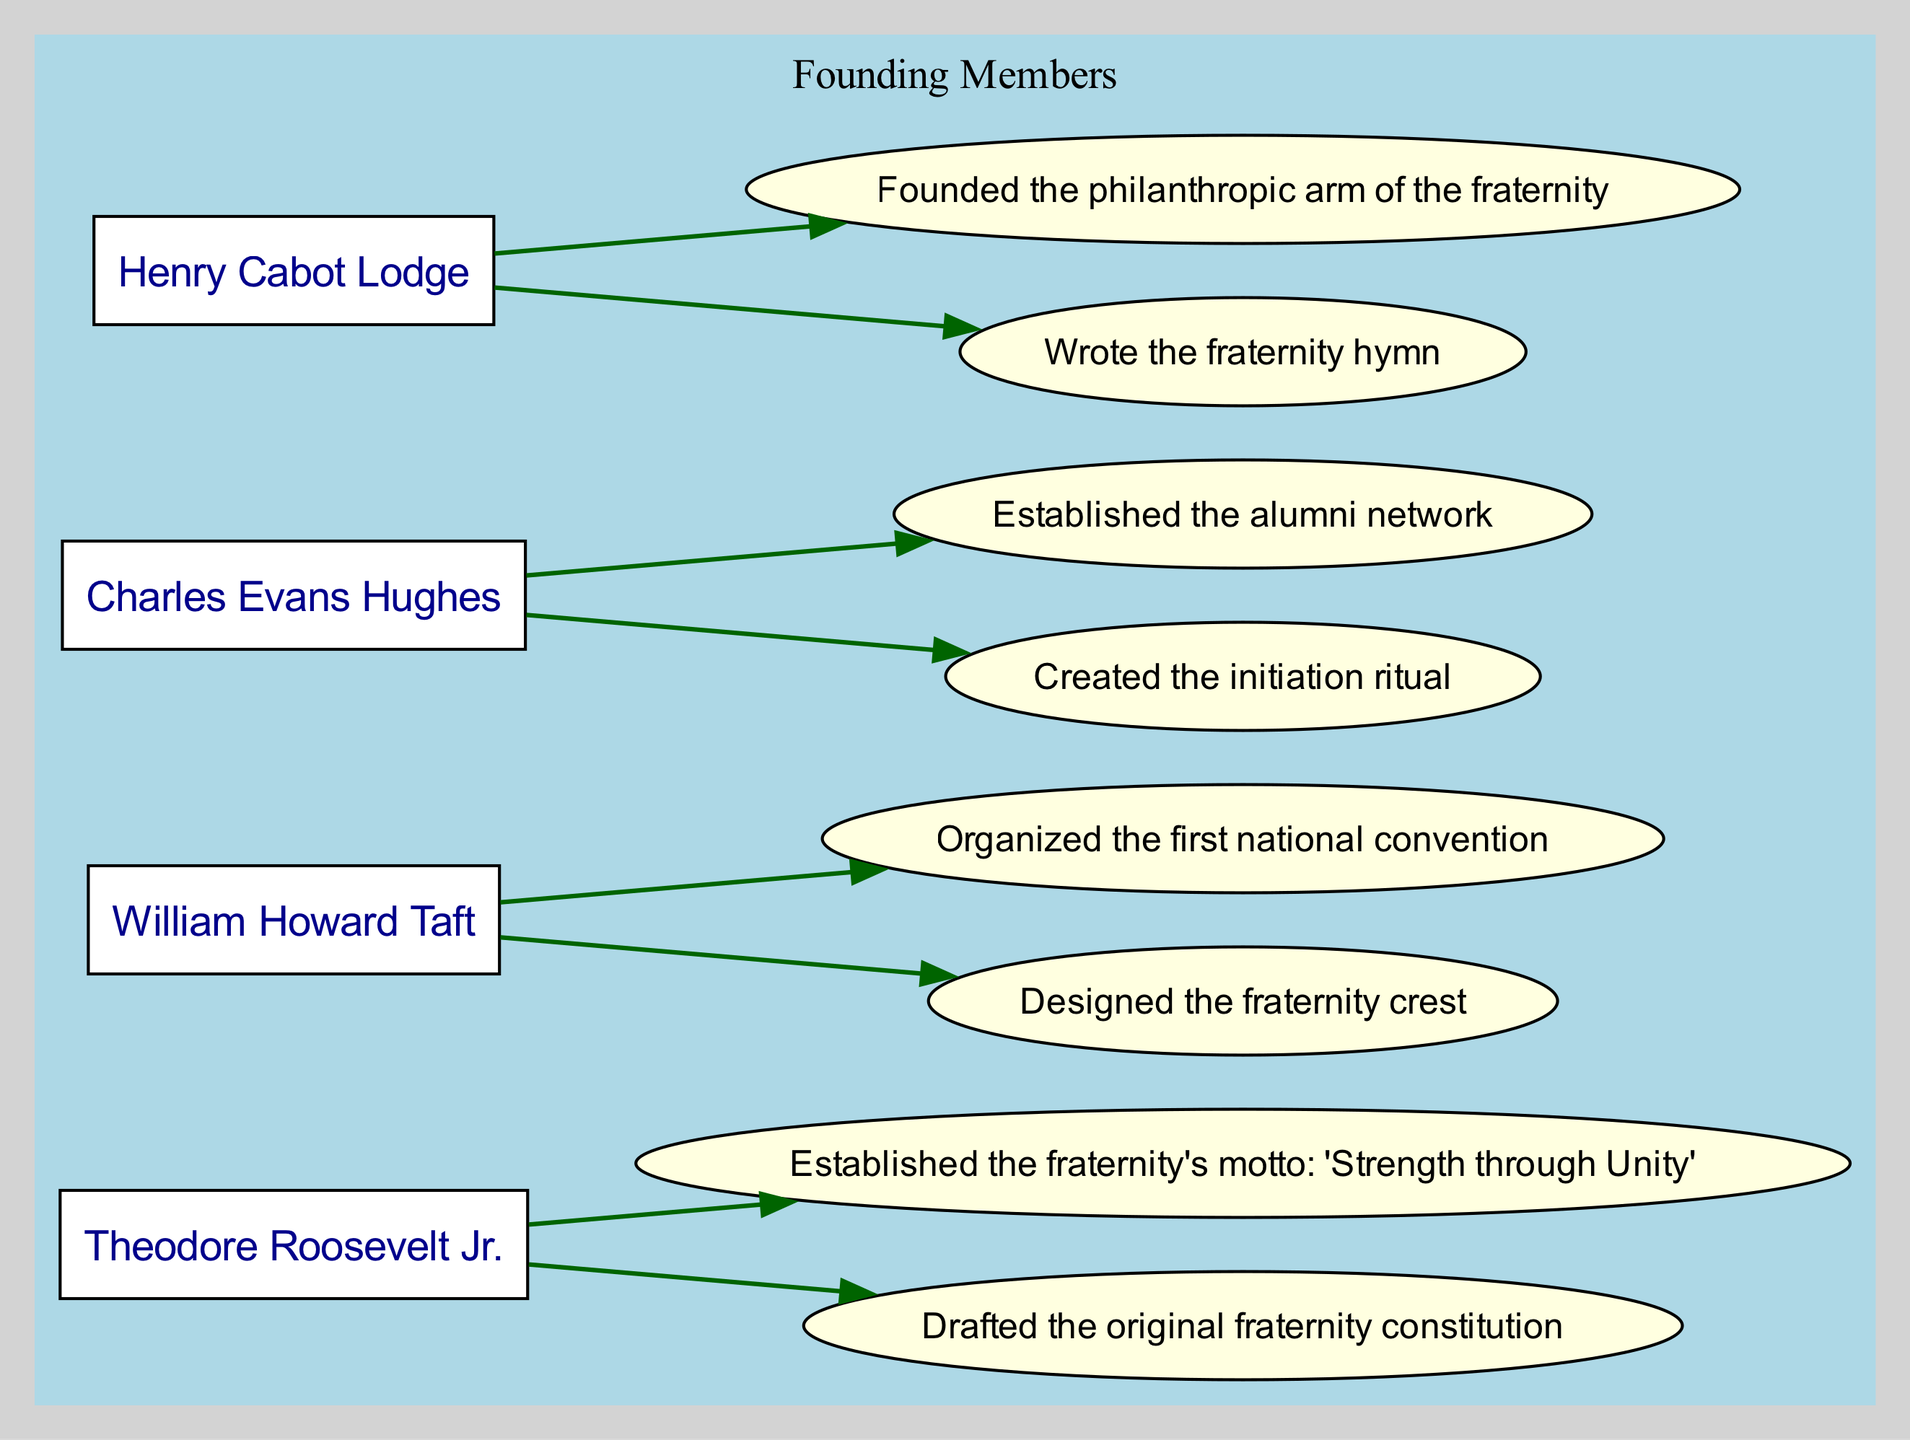What is the first name of the founding member who drafted the original fraternity constitution? The diagram indicates that Theodore Roosevelt Jr. is the one who drafted the original fraternity constitution. This is directly captured in his contributions listed under his name.
Answer: Theodore What contribution did William Howard Taft make? According to the diagram, one of William Howard Taft's contributions is that he designed the fraternity crest. This information can be found under his contributions listed nearby his name.
Answer: Designed the fraternity crest How many founding members are illustrated in the diagram? By counting the nodes labeled with names in the diagram, there are four founding members displayed: Theodore Roosevelt Jr., William Howard Taft, Charles Evans Hughes, and Henry Cabot Lodge.
Answer: 4 Which member is associated with the creation of the initiation ritual? Upon examining the contributions outlined in the diagram, it is clear that Charles Evans Hughes is responsible for creating the initiation ritual. This is listed among his contributions.
Answer: Charles Evans Hughes What phrase defines the fraternity's motto as per the contributions of the founding members? The diagram points to the motto 'Strength through Unity' as established by Theodore Roosevelt Jr. This information is specifically noted as part of his contributions.
Answer: Strength through Unity Who founded the philanthropic arm of the fraternity? The diagram shows that Henry Cabot Lodge is credited with founding the philanthropic arm of the fraternity. This contribution is clearly listed under his name in the contributions section.
Answer: Henry Cabot Lodge Which founding member is connected to the phrase "founded the alumni network"? In looking at the contributions outlined in the diagram, Charles Evans Hughes is noted for establishing the alumni network, linking him to that specific phrase.
Answer: Charles Evans Hughes What is the relationship between Theodore Roosevelt Jr. and the fraternity's motto? The diagram illustrates that Theodore Roosevelt Jr. established the motto 'Strength through Unity', indicating a direct contribution of his to the fraternity's guiding principles.
Answer: Established the motto What collective function do the contributions of all founding members serve? The contributions of all founding members together illustrate the foundation of the fraternity's structure, traditions, and community ties, highlighting their essential roles in shaping the organization's values and operations.
Answer: Foundation of fraternity's structure 